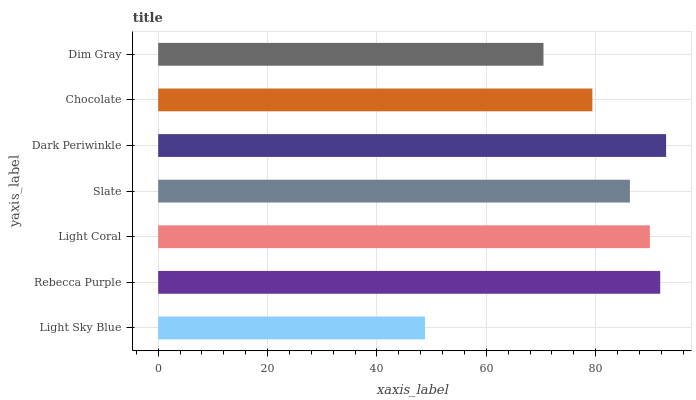Is Light Sky Blue the minimum?
Answer yes or no. Yes. Is Dark Periwinkle the maximum?
Answer yes or no. Yes. Is Rebecca Purple the minimum?
Answer yes or no. No. Is Rebecca Purple the maximum?
Answer yes or no. No. Is Rebecca Purple greater than Light Sky Blue?
Answer yes or no. Yes. Is Light Sky Blue less than Rebecca Purple?
Answer yes or no. Yes. Is Light Sky Blue greater than Rebecca Purple?
Answer yes or no. No. Is Rebecca Purple less than Light Sky Blue?
Answer yes or no. No. Is Slate the high median?
Answer yes or no. Yes. Is Slate the low median?
Answer yes or no. Yes. Is Dim Gray the high median?
Answer yes or no. No. Is Dim Gray the low median?
Answer yes or no. No. 